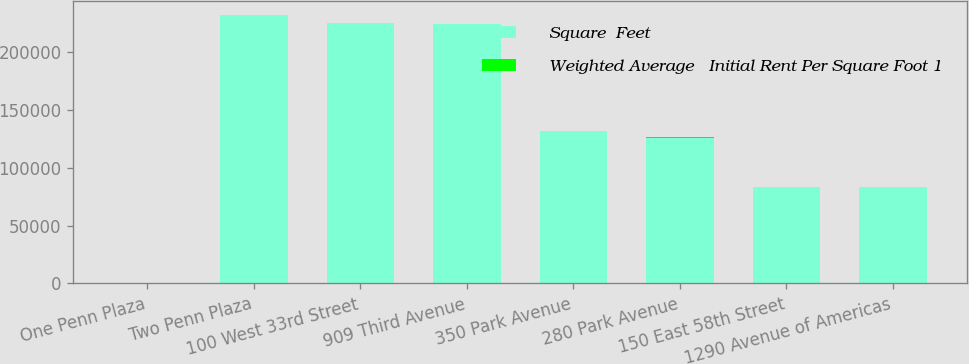<chart> <loc_0><loc_0><loc_500><loc_500><stacked_bar_chart><ecel><fcel>One Penn Plaza<fcel>Two Penn Plaza<fcel>100 West 33rd Street<fcel>909 Third Avenue<fcel>350 Park Avenue<fcel>280 Park Avenue<fcel>150 East 58th Street<fcel>1290 Avenue of Americas<nl><fcel>Square  Feet<fcel>81.75<fcel>232000<fcel>225000<fcel>224000<fcel>132000<fcel>126000<fcel>83000<fcel>83000<nl><fcel>Weighted Average   Initial Rent Per Square Foot 1<fcel>59.37<fcel>47.45<fcel>45.79<fcel>50.08<fcel>78.91<fcel>81.75<fcel>59.84<fcel>70<nl></chart> 